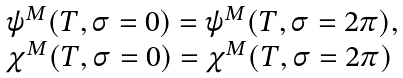Convert formula to latex. <formula><loc_0><loc_0><loc_500><loc_500>\begin{array} { l } \psi ^ { M } ( T , \sigma = 0 ) = \psi ^ { M } ( T , \sigma = 2 \pi ) , \\ \chi ^ { M } ( T , \sigma = 0 ) = \chi ^ { M } ( T , \sigma = 2 \pi ) \end{array}</formula> 